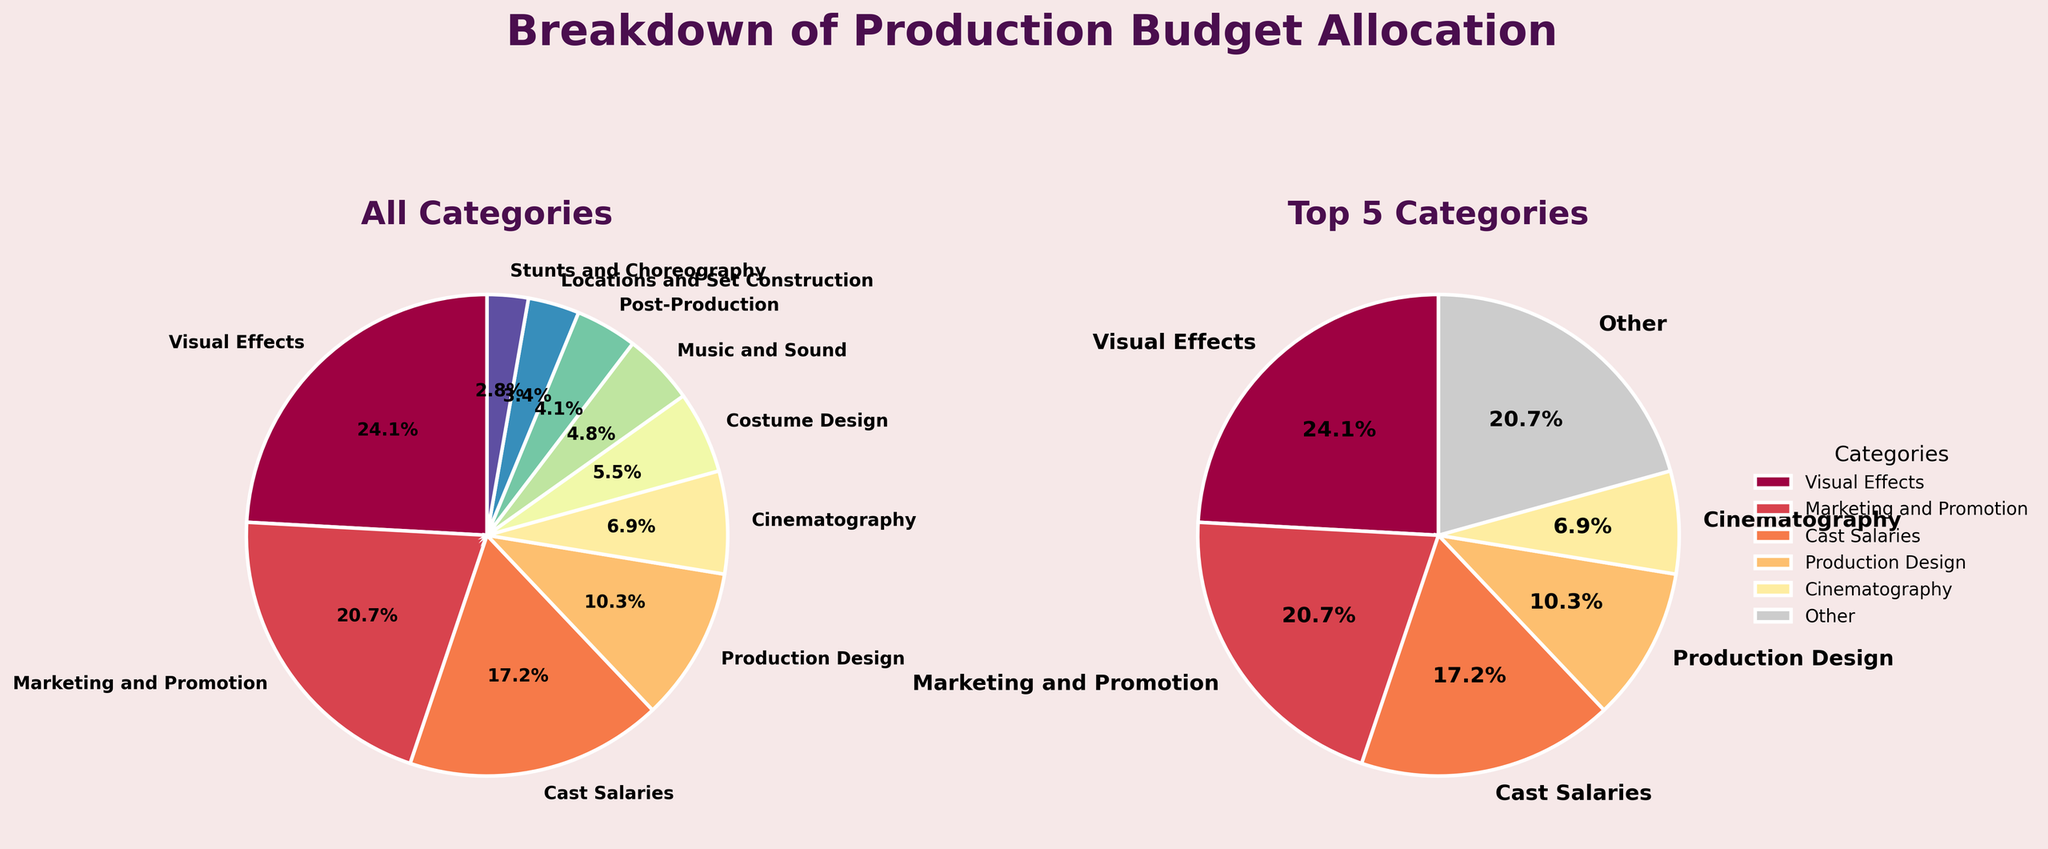What is the title of the figure? The figure's title is prominently displayed at the top, stating "Breakdown of Production Budget Allocation".
Answer: Breakdown of Production Budget Allocation What percentage of the budget is allocated to Visual Effects? In the "All Categories" pie chart, Visual Effects' wedge is labeled with the percentage, which is also corroborated in the "Top 5 Categories" pie chart.
Answer: 23.3% Which category has the smallest budget allocation? By looking at the smallest wedges in the "All Categories" pie chart and their labels, the category with the smallest allocation can be identified.
Answer: Stunts and Choreography How much is allocated to "Other" in the "Top 5 Categories" pie chart? In the "Top 5 Categories" pie chart, 'Other' is one of the slices, and its percentage is provided on the pie chart. To find the amount, multiply the total budget by this percentage.
Answer: 14.6% What is the combined budget allocation percentage for Cast Salaries and Production Design? Refer to the "All Categories" pie chart for the percentages of both Cast Salaries and Production Design, then add them together.
Answer: 16.7% + 10.0% = 26.7% Are Cast Salaries allocated a higher budget than Marketing and Promotion? By comparing the sizes of their respective wedges and percentages in the "All Categories" pie chart, it can be determined which one is larger.
Answer: No What is the second largest budget category? By looking at the sizes of the wedges and their percentages in the "All Categories" pie chart, the second largest category can be determined.
Answer: Marketing and Promotion How does the allocation for Costume Design compare with Music and Sound? Check the "All Categories" pie chart for the percentages or sizes of the wedges labeled Costume Design and Music and Sound to compare which one is larger.
Answer: Costume Design is larger If the total budget is $120,000,000, how much is allocated to post-production? Refer to the "All Categories" pie chart to get the percentage for Post-Production, and multiply this percentage by the total budget.
Answer: $7,200,000 Does the "Top 5 Categories" pie chart include Music and Sound? By analyzing the labels in the "Top 5 Categories" pie chart, we can determine if Music and Sound is represented or combined in 'Other'.
Answer: No 